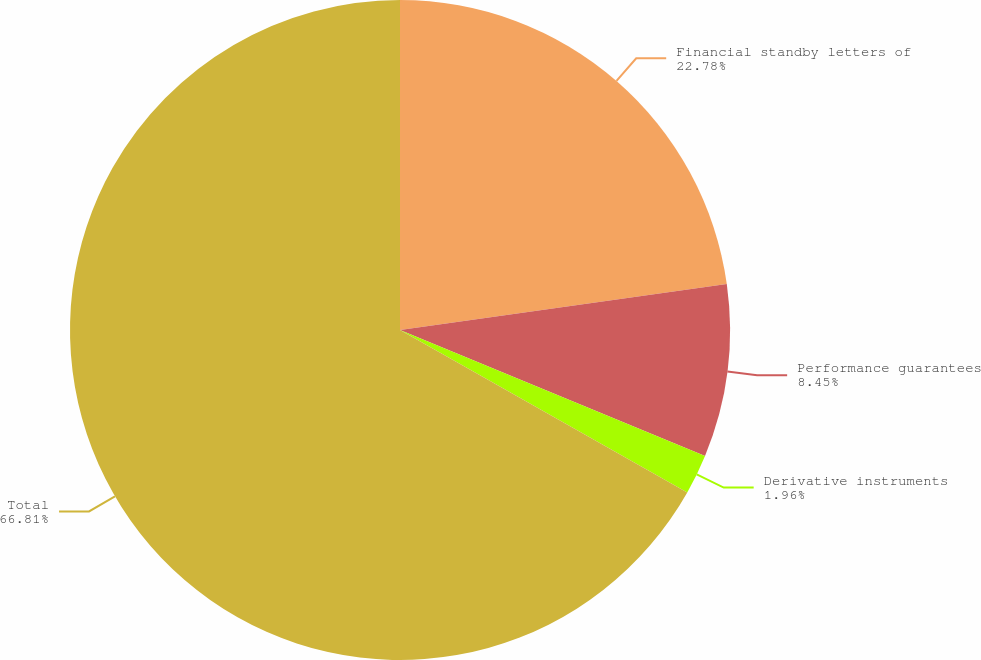<chart> <loc_0><loc_0><loc_500><loc_500><pie_chart><fcel>Financial standby letters of<fcel>Performance guarantees<fcel>Derivative instruments<fcel>Total<nl><fcel>22.78%<fcel>8.45%<fcel>1.96%<fcel>66.81%<nl></chart> 